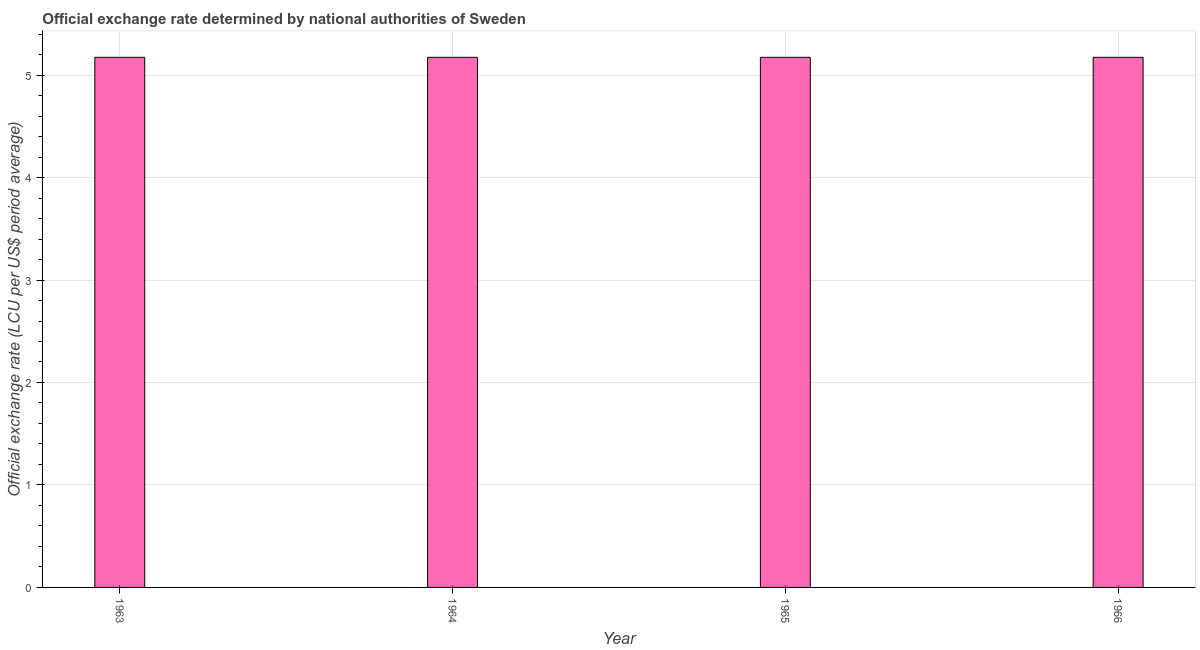Does the graph contain grids?
Your answer should be compact. Yes. What is the title of the graph?
Give a very brief answer. Official exchange rate determined by national authorities of Sweden. What is the label or title of the Y-axis?
Ensure brevity in your answer.  Official exchange rate (LCU per US$ period average). What is the official exchange rate in 1965?
Ensure brevity in your answer.  5.17. Across all years, what is the maximum official exchange rate?
Keep it short and to the point. 5.17. Across all years, what is the minimum official exchange rate?
Keep it short and to the point. 5.17. In which year was the official exchange rate minimum?
Your answer should be very brief. 1963. What is the sum of the official exchange rate?
Ensure brevity in your answer.  20.69. What is the difference between the official exchange rate in 1963 and 1966?
Your answer should be very brief. 0. What is the average official exchange rate per year?
Provide a succinct answer. 5.17. What is the median official exchange rate?
Offer a terse response. 5.17. In how many years, is the official exchange rate greater than 3.6 ?
Offer a terse response. 4. Is the official exchange rate in 1963 less than that in 1966?
Your answer should be compact. No. What is the difference between the highest and the second highest official exchange rate?
Offer a very short reply. 0. What is the difference between the highest and the lowest official exchange rate?
Provide a short and direct response. 0. In how many years, is the official exchange rate greater than the average official exchange rate taken over all years?
Provide a succinct answer. 0. What is the Official exchange rate (LCU per US$ period average) in 1963?
Offer a very short reply. 5.17. What is the Official exchange rate (LCU per US$ period average) of 1964?
Your response must be concise. 5.17. What is the Official exchange rate (LCU per US$ period average) in 1965?
Offer a very short reply. 5.17. What is the Official exchange rate (LCU per US$ period average) in 1966?
Provide a short and direct response. 5.17. What is the difference between the Official exchange rate (LCU per US$ period average) in 1963 and 1964?
Provide a short and direct response. 0. What is the difference between the Official exchange rate (LCU per US$ period average) in 1963 and 1965?
Offer a very short reply. 0. What is the difference between the Official exchange rate (LCU per US$ period average) in 1963 and 1966?
Give a very brief answer. 0. What is the difference between the Official exchange rate (LCU per US$ period average) in 1965 and 1966?
Give a very brief answer. 0. What is the ratio of the Official exchange rate (LCU per US$ period average) in 1963 to that in 1964?
Give a very brief answer. 1. What is the ratio of the Official exchange rate (LCU per US$ period average) in 1963 to that in 1965?
Offer a terse response. 1. What is the ratio of the Official exchange rate (LCU per US$ period average) in 1963 to that in 1966?
Your answer should be compact. 1. What is the ratio of the Official exchange rate (LCU per US$ period average) in 1964 to that in 1965?
Your response must be concise. 1. What is the ratio of the Official exchange rate (LCU per US$ period average) in 1964 to that in 1966?
Keep it short and to the point. 1. What is the ratio of the Official exchange rate (LCU per US$ period average) in 1965 to that in 1966?
Provide a short and direct response. 1. 